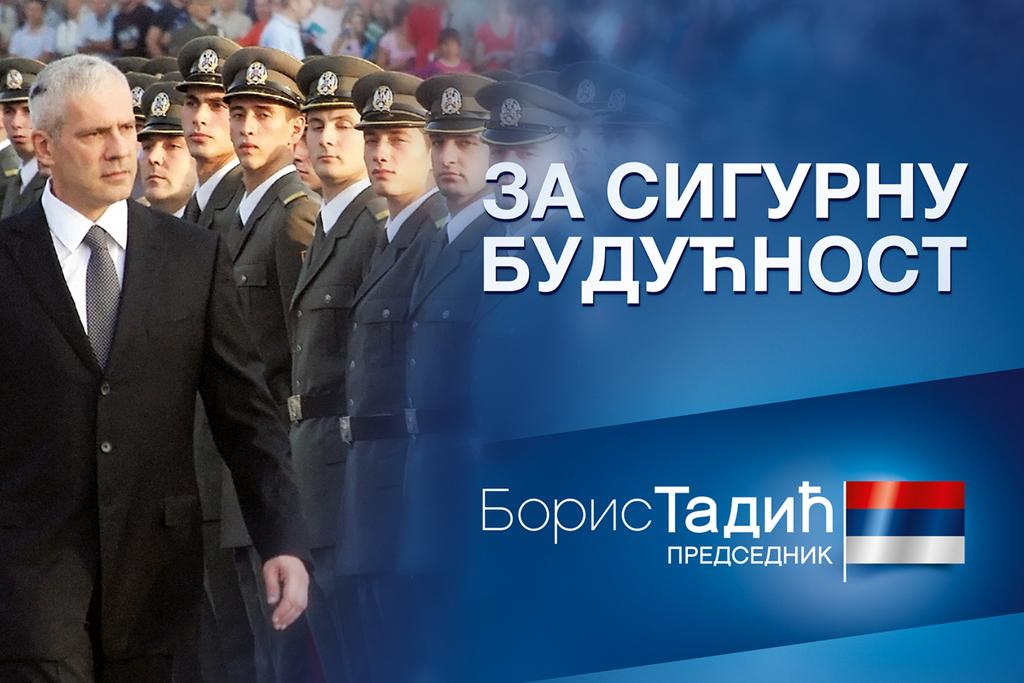What is located on the right side of the image? There is a flag on the right side of the image. What is the background of the flag? The flag is on a blue screen. What can be seen on the left side of the image? There are many people on the left side of the image. What are the people doing in the image? The people are standing and looking somewhere. How many railway tracks can be seen in the image? There are no railway tracks present in the image. What type of twig is being used by the people in the image? There is no twig present in the image; the people are standing and looking somewhere. 